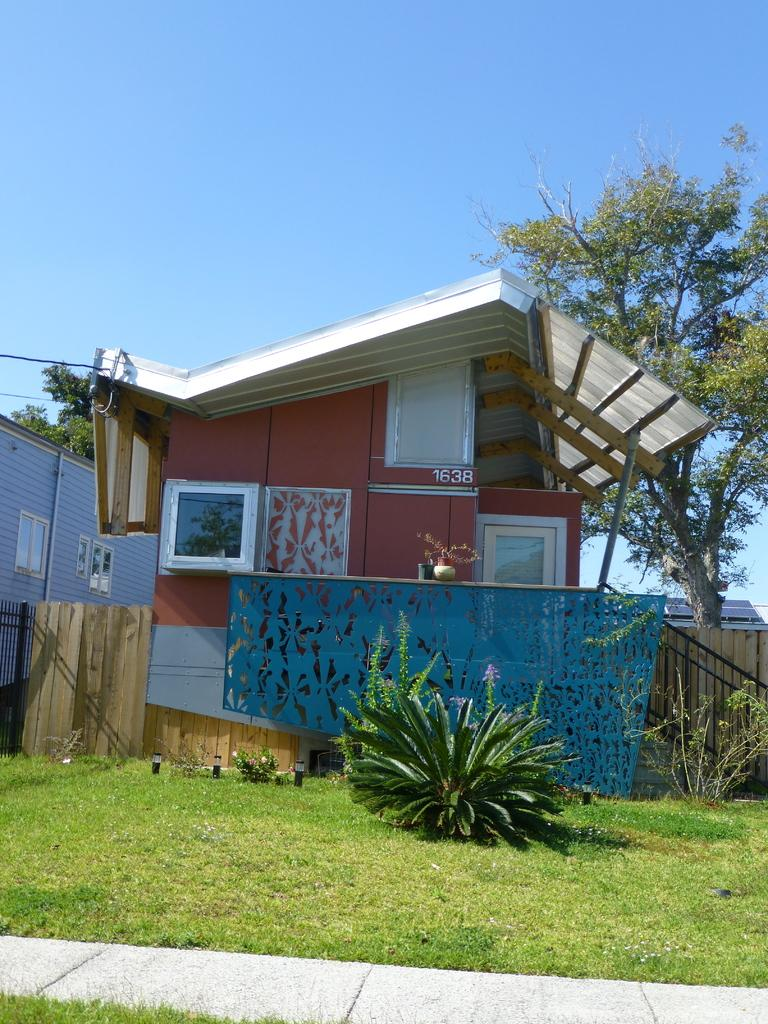What type of vegetation is present in the image? There is grass in the image, as well as plants and trees in the background. What kind of surface can be seen in the image? There is a path in the image. What is visible in the background of the image? There is a building, trees, and the sky visible in the background of the image. How many giraffes can be seen grazing on the vegetable in the image? There are no giraffes or vegetables present in the image. 